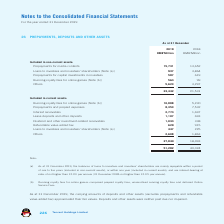According to Tencent's financial document, What did the running royalty fees for online games comprise of? prepaid royalty fees, unamortised running royalty fees and deferred Online Service Fees. The document states: ") Running royalty fees for online games comprised prepaid royalty fees, unamortised running royalty fees and deferred Online Service Fees...." Also, How much was the prepayment for media contents as at 31 December 2018? According to the financial document, 13,652 (in millions). The relevant text states: "Prepayments for media contents 15,731 13,652..." Also, How much was the prepayment for media contents as at 31 December 2019? According to the financial document, 15,731 (in millions). The relevant text states: "Prepayments for media contents 15,731 13,652..." Also, can you calculate: How much did the prepayments for media contents change by between 2018 year end and 2019 year end? Based on the calculation: 15,731-13,652, the result is 2079 (in millions). This is based on the information: "Prepayments for media contents 15,731 13,652 Prepayments for media contents 15,731 13,652..." The key data points involved are: 13,652, 15,731. Also, can you calculate: How much did the prepayments and prepaid expenses change by between 2018 year end and 2019 year end? Based on the calculation: 8,353-7,532, the result is 821 (in millions). This is based on the information: "Prepayments and prepaid expenses 8,353 7,532 Prepayments and prepaid expenses 8,353 7,532..." The key data points involved are: 7,532, 8,353. Also, can you calculate: How much did the interest receivables between 2018 year end and 2019 year end change by? Based on the calculation: 2,774-1,697, the result is 1077 (in millions). This is based on the information: "Interest receivables 2,774 1,697 Interest receivables 2,774 1,697..." The key data points involved are: 1,697, 2,774. 